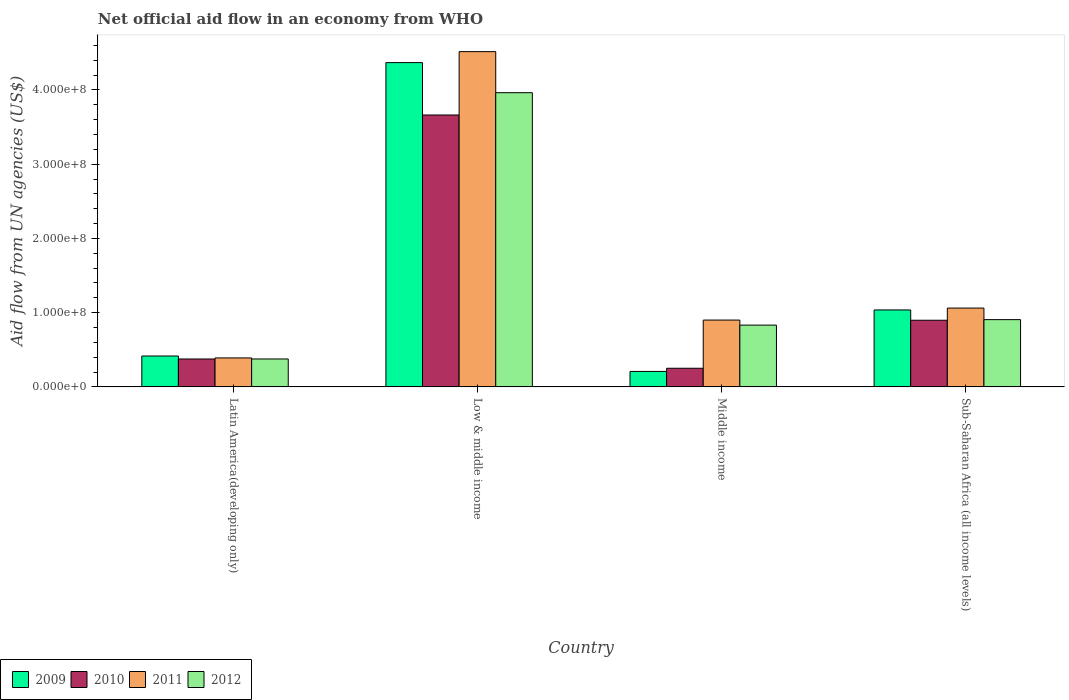Are the number of bars per tick equal to the number of legend labels?
Ensure brevity in your answer.  Yes. Are the number of bars on each tick of the X-axis equal?
Give a very brief answer. Yes. How many bars are there on the 3rd tick from the right?
Provide a succinct answer. 4. What is the label of the 3rd group of bars from the left?
Keep it short and to the point. Middle income. In how many cases, is the number of bars for a given country not equal to the number of legend labels?
Make the answer very short. 0. What is the net official aid flow in 2009 in Middle income?
Give a very brief answer. 2.08e+07. Across all countries, what is the maximum net official aid flow in 2009?
Provide a short and direct response. 4.37e+08. Across all countries, what is the minimum net official aid flow in 2009?
Offer a terse response. 2.08e+07. In which country was the net official aid flow in 2012 minimum?
Provide a succinct answer. Latin America(developing only). What is the total net official aid flow in 2012 in the graph?
Provide a short and direct response. 6.08e+08. What is the difference between the net official aid flow in 2011 in Latin America(developing only) and that in Sub-Saharan Africa (all income levels)?
Ensure brevity in your answer.  -6.72e+07. What is the difference between the net official aid flow in 2010 in Sub-Saharan Africa (all income levels) and the net official aid flow in 2009 in Middle income?
Make the answer very short. 6.90e+07. What is the average net official aid flow in 2009 per country?
Your response must be concise. 1.51e+08. What is the difference between the net official aid flow of/in 2012 and net official aid flow of/in 2010 in Low & middle income?
Provide a succinct answer. 3.00e+07. In how many countries, is the net official aid flow in 2012 greater than 440000000 US$?
Keep it short and to the point. 0. What is the ratio of the net official aid flow in 2011 in Latin America(developing only) to that in Sub-Saharan Africa (all income levels)?
Give a very brief answer. 0.37. Is the difference between the net official aid flow in 2012 in Latin America(developing only) and Low & middle income greater than the difference between the net official aid flow in 2010 in Latin America(developing only) and Low & middle income?
Your answer should be compact. No. What is the difference between the highest and the second highest net official aid flow in 2012?
Your response must be concise. 3.06e+08. What is the difference between the highest and the lowest net official aid flow in 2009?
Ensure brevity in your answer.  4.16e+08. Is it the case that in every country, the sum of the net official aid flow in 2012 and net official aid flow in 2009 is greater than the sum of net official aid flow in 2011 and net official aid flow in 2010?
Offer a very short reply. No. What does the 4th bar from the right in Middle income represents?
Ensure brevity in your answer.  2009. How many bars are there?
Make the answer very short. 16. Are all the bars in the graph horizontal?
Make the answer very short. No. How many countries are there in the graph?
Ensure brevity in your answer.  4. Does the graph contain grids?
Your response must be concise. No. How many legend labels are there?
Provide a succinct answer. 4. How are the legend labels stacked?
Provide a succinct answer. Horizontal. What is the title of the graph?
Your response must be concise. Net official aid flow in an economy from WHO. What is the label or title of the Y-axis?
Your answer should be very brief. Aid flow from UN agencies (US$). What is the Aid flow from UN agencies (US$) in 2009 in Latin America(developing only)?
Keep it short and to the point. 4.16e+07. What is the Aid flow from UN agencies (US$) of 2010 in Latin America(developing only)?
Provide a succinct answer. 3.76e+07. What is the Aid flow from UN agencies (US$) in 2011 in Latin America(developing only)?
Keep it short and to the point. 3.90e+07. What is the Aid flow from UN agencies (US$) of 2012 in Latin America(developing only)?
Ensure brevity in your answer.  3.76e+07. What is the Aid flow from UN agencies (US$) in 2009 in Low & middle income?
Your answer should be compact. 4.37e+08. What is the Aid flow from UN agencies (US$) in 2010 in Low & middle income?
Ensure brevity in your answer.  3.66e+08. What is the Aid flow from UN agencies (US$) of 2011 in Low & middle income?
Your response must be concise. 4.52e+08. What is the Aid flow from UN agencies (US$) of 2012 in Low & middle income?
Ensure brevity in your answer.  3.96e+08. What is the Aid flow from UN agencies (US$) in 2009 in Middle income?
Offer a very short reply. 2.08e+07. What is the Aid flow from UN agencies (US$) in 2010 in Middle income?
Provide a short and direct response. 2.51e+07. What is the Aid flow from UN agencies (US$) in 2011 in Middle income?
Ensure brevity in your answer.  9.00e+07. What is the Aid flow from UN agencies (US$) in 2012 in Middle income?
Provide a succinct answer. 8.32e+07. What is the Aid flow from UN agencies (US$) in 2009 in Sub-Saharan Africa (all income levels)?
Provide a succinct answer. 1.04e+08. What is the Aid flow from UN agencies (US$) of 2010 in Sub-Saharan Africa (all income levels)?
Ensure brevity in your answer.  8.98e+07. What is the Aid flow from UN agencies (US$) of 2011 in Sub-Saharan Africa (all income levels)?
Your response must be concise. 1.06e+08. What is the Aid flow from UN agencies (US$) in 2012 in Sub-Saharan Africa (all income levels)?
Offer a terse response. 9.06e+07. Across all countries, what is the maximum Aid flow from UN agencies (US$) in 2009?
Provide a succinct answer. 4.37e+08. Across all countries, what is the maximum Aid flow from UN agencies (US$) of 2010?
Your answer should be very brief. 3.66e+08. Across all countries, what is the maximum Aid flow from UN agencies (US$) of 2011?
Your response must be concise. 4.52e+08. Across all countries, what is the maximum Aid flow from UN agencies (US$) in 2012?
Offer a terse response. 3.96e+08. Across all countries, what is the minimum Aid flow from UN agencies (US$) of 2009?
Your answer should be compact. 2.08e+07. Across all countries, what is the minimum Aid flow from UN agencies (US$) in 2010?
Ensure brevity in your answer.  2.51e+07. Across all countries, what is the minimum Aid flow from UN agencies (US$) of 2011?
Offer a terse response. 3.90e+07. Across all countries, what is the minimum Aid flow from UN agencies (US$) in 2012?
Your response must be concise. 3.76e+07. What is the total Aid flow from UN agencies (US$) of 2009 in the graph?
Your response must be concise. 6.03e+08. What is the total Aid flow from UN agencies (US$) of 2010 in the graph?
Ensure brevity in your answer.  5.19e+08. What is the total Aid flow from UN agencies (US$) in 2011 in the graph?
Your response must be concise. 6.87e+08. What is the total Aid flow from UN agencies (US$) in 2012 in the graph?
Give a very brief answer. 6.08e+08. What is the difference between the Aid flow from UN agencies (US$) in 2009 in Latin America(developing only) and that in Low & middle income?
Provide a short and direct response. -3.95e+08. What is the difference between the Aid flow from UN agencies (US$) of 2010 in Latin America(developing only) and that in Low & middle income?
Provide a short and direct response. -3.29e+08. What is the difference between the Aid flow from UN agencies (US$) in 2011 in Latin America(developing only) and that in Low & middle income?
Keep it short and to the point. -4.13e+08. What is the difference between the Aid flow from UN agencies (US$) of 2012 in Latin America(developing only) and that in Low & middle income?
Your answer should be compact. -3.59e+08. What is the difference between the Aid flow from UN agencies (US$) of 2009 in Latin America(developing only) and that in Middle income?
Provide a succinct answer. 2.08e+07. What is the difference between the Aid flow from UN agencies (US$) of 2010 in Latin America(developing only) and that in Middle income?
Offer a terse response. 1.25e+07. What is the difference between the Aid flow from UN agencies (US$) of 2011 in Latin America(developing only) and that in Middle income?
Make the answer very short. -5.10e+07. What is the difference between the Aid flow from UN agencies (US$) in 2012 in Latin America(developing only) and that in Middle income?
Your answer should be very brief. -4.56e+07. What is the difference between the Aid flow from UN agencies (US$) in 2009 in Latin America(developing only) and that in Sub-Saharan Africa (all income levels)?
Provide a succinct answer. -6.20e+07. What is the difference between the Aid flow from UN agencies (US$) in 2010 in Latin America(developing only) and that in Sub-Saharan Africa (all income levels)?
Offer a very short reply. -5.22e+07. What is the difference between the Aid flow from UN agencies (US$) in 2011 in Latin America(developing only) and that in Sub-Saharan Africa (all income levels)?
Your response must be concise. -6.72e+07. What is the difference between the Aid flow from UN agencies (US$) of 2012 in Latin America(developing only) and that in Sub-Saharan Africa (all income levels)?
Give a very brief answer. -5.30e+07. What is the difference between the Aid flow from UN agencies (US$) in 2009 in Low & middle income and that in Middle income?
Offer a terse response. 4.16e+08. What is the difference between the Aid flow from UN agencies (US$) in 2010 in Low & middle income and that in Middle income?
Give a very brief answer. 3.41e+08. What is the difference between the Aid flow from UN agencies (US$) of 2011 in Low & middle income and that in Middle income?
Ensure brevity in your answer.  3.62e+08. What is the difference between the Aid flow from UN agencies (US$) in 2012 in Low & middle income and that in Middle income?
Your answer should be compact. 3.13e+08. What is the difference between the Aid flow from UN agencies (US$) in 2009 in Low & middle income and that in Sub-Saharan Africa (all income levels)?
Provide a short and direct response. 3.33e+08. What is the difference between the Aid flow from UN agencies (US$) of 2010 in Low & middle income and that in Sub-Saharan Africa (all income levels)?
Give a very brief answer. 2.76e+08. What is the difference between the Aid flow from UN agencies (US$) in 2011 in Low & middle income and that in Sub-Saharan Africa (all income levels)?
Give a very brief answer. 3.45e+08. What is the difference between the Aid flow from UN agencies (US$) in 2012 in Low & middle income and that in Sub-Saharan Africa (all income levels)?
Your answer should be compact. 3.06e+08. What is the difference between the Aid flow from UN agencies (US$) of 2009 in Middle income and that in Sub-Saharan Africa (all income levels)?
Give a very brief answer. -8.28e+07. What is the difference between the Aid flow from UN agencies (US$) in 2010 in Middle income and that in Sub-Saharan Africa (all income levels)?
Offer a very short reply. -6.47e+07. What is the difference between the Aid flow from UN agencies (US$) in 2011 in Middle income and that in Sub-Saharan Africa (all income levels)?
Ensure brevity in your answer.  -1.62e+07. What is the difference between the Aid flow from UN agencies (US$) in 2012 in Middle income and that in Sub-Saharan Africa (all income levels)?
Keep it short and to the point. -7.39e+06. What is the difference between the Aid flow from UN agencies (US$) of 2009 in Latin America(developing only) and the Aid flow from UN agencies (US$) of 2010 in Low & middle income?
Your answer should be compact. -3.25e+08. What is the difference between the Aid flow from UN agencies (US$) in 2009 in Latin America(developing only) and the Aid flow from UN agencies (US$) in 2011 in Low & middle income?
Your answer should be compact. -4.10e+08. What is the difference between the Aid flow from UN agencies (US$) of 2009 in Latin America(developing only) and the Aid flow from UN agencies (US$) of 2012 in Low & middle income?
Your answer should be very brief. -3.55e+08. What is the difference between the Aid flow from UN agencies (US$) in 2010 in Latin America(developing only) and the Aid flow from UN agencies (US$) in 2011 in Low & middle income?
Provide a short and direct response. -4.14e+08. What is the difference between the Aid flow from UN agencies (US$) of 2010 in Latin America(developing only) and the Aid flow from UN agencies (US$) of 2012 in Low & middle income?
Ensure brevity in your answer.  -3.59e+08. What is the difference between the Aid flow from UN agencies (US$) in 2011 in Latin America(developing only) and the Aid flow from UN agencies (US$) in 2012 in Low & middle income?
Your answer should be very brief. -3.57e+08. What is the difference between the Aid flow from UN agencies (US$) of 2009 in Latin America(developing only) and the Aid flow from UN agencies (US$) of 2010 in Middle income?
Your response must be concise. 1.65e+07. What is the difference between the Aid flow from UN agencies (US$) of 2009 in Latin America(developing only) and the Aid flow from UN agencies (US$) of 2011 in Middle income?
Keep it short and to the point. -4.84e+07. What is the difference between the Aid flow from UN agencies (US$) in 2009 in Latin America(developing only) and the Aid flow from UN agencies (US$) in 2012 in Middle income?
Keep it short and to the point. -4.16e+07. What is the difference between the Aid flow from UN agencies (US$) in 2010 in Latin America(developing only) and the Aid flow from UN agencies (US$) in 2011 in Middle income?
Give a very brief answer. -5.24e+07. What is the difference between the Aid flow from UN agencies (US$) in 2010 in Latin America(developing only) and the Aid flow from UN agencies (US$) in 2012 in Middle income?
Your answer should be very brief. -4.56e+07. What is the difference between the Aid flow from UN agencies (US$) of 2011 in Latin America(developing only) and the Aid flow from UN agencies (US$) of 2012 in Middle income?
Your answer should be very brief. -4.42e+07. What is the difference between the Aid flow from UN agencies (US$) of 2009 in Latin America(developing only) and the Aid flow from UN agencies (US$) of 2010 in Sub-Saharan Africa (all income levels)?
Provide a short and direct response. -4.82e+07. What is the difference between the Aid flow from UN agencies (US$) of 2009 in Latin America(developing only) and the Aid flow from UN agencies (US$) of 2011 in Sub-Saharan Africa (all income levels)?
Offer a very short reply. -6.46e+07. What is the difference between the Aid flow from UN agencies (US$) of 2009 in Latin America(developing only) and the Aid flow from UN agencies (US$) of 2012 in Sub-Saharan Africa (all income levels)?
Your answer should be very brief. -4.90e+07. What is the difference between the Aid flow from UN agencies (US$) of 2010 in Latin America(developing only) and the Aid flow from UN agencies (US$) of 2011 in Sub-Saharan Africa (all income levels)?
Ensure brevity in your answer.  -6.86e+07. What is the difference between the Aid flow from UN agencies (US$) in 2010 in Latin America(developing only) and the Aid flow from UN agencies (US$) in 2012 in Sub-Saharan Africa (all income levels)?
Keep it short and to the point. -5.30e+07. What is the difference between the Aid flow from UN agencies (US$) of 2011 in Latin America(developing only) and the Aid flow from UN agencies (US$) of 2012 in Sub-Saharan Africa (all income levels)?
Your answer should be compact. -5.16e+07. What is the difference between the Aid flow from UN agencies (US$) of 2009 in Low & middle income and the Aid flow from UN agencies (US$) of 2010 in Middle income?
Your response must be concise. 4.12e+08. What is the difference between the Aid flow from UN agencies (US$) in 2009 in Low & middle income and the Aid flow from UN agencies (US$) in 2011 in Middle income?
Offer a very short reply. 3.47e+08. What is the difference between the Aid flow from UN agencies (US$) of 2009 in Low & middle income and the Aid flow from UN agencies (US$) of 2012 in Middle income?
Offer a terse response. 3.54e+08. What is the difference between the Aid flow from UN agencies (US$) of 2010 in Low & middle income and the Aid flow from UN agencies (US$) of 2011 in Middle income?
Give a very brief answer. 2.76e+08. What is the difference between the Aid flow from UN agencies (US$) of 2010 in Low & middle income and the Aid flow from UN agencies (US$) of 2012 in Middle income?
Provide a succinct answer. 2.83e+08. What is the difference between the Aid flow from UN agencies (US$) of 2011 in Low & middle income and the Aid flow from UN agencies (US$) of 2012 in Middle income?
Your answer should be very brief. 3.68e+08. What is the difference between the Aid flow from UN agencies (US$) in 2009 in Low & middle income and the Aid flow from UN agencies (US$) in 2010 in Sub-Saharan Africa (all income levels)?
Ensure brevity in your answer.  3.47e+08. What is the difference between the Aid flow from UN agencies (US$) in 2009 in Low & middle income and the Aid flow from UN agencies (US$) in 2011 in Sub-Saharan Africa (all income levels)?
Offer a very short reply. 3.31e+08. What is the difference between the Aid flow from UN agencies (US$) of 2009 in Low & middle income and the Aid flow from UN agencies (US$) of 2012 in Sub-Saharan Africa (all income levels)?
Offer a terse response. 3.46e+08. What is the difference between the Aid flow from UN agencies (US$) in 2010 in Low & middle income and the Aid flow from UN agencies (US$) in 2011 in Sub-Saharan Africa (all income levels)?
Your answer should be compact. 2.60e+08. What is the difference between the Aid flow from UN agencies (US$) in 2010 in Low & middle income and the Aid flow from UN agencies (US$) in 2012 in Sub-Saharan Africa (all income levels)?
Offer a very short reply. 2.76e+08. What is the difference between the Aid flow from UN agencies (US$) in 2011 in Low & middle income and the Aid flow from UN agencies (US$) in 2012 in Sub-Saharan Africa (all income levels)?
Provide a succinct answer. 3.61e+08. What is the difference between the Aid flow from UN agencies (US$) of 2009 in Middle income and the Aid flow from UN agencies (US$) of 2010 in Sub-Saharan Africa (all income levels)?
Make the answer very short. -6.90e+07. What is the difference between the Aid flow from UN agencies (US$) of 2009 in Middle income and the Aid flow from UN agencies (US$) of 2011 in Sub-Saharan Africa (all income levels)?
Your answer should be very brief. -8.54e+07. What is the difference between the Aid flow from UN agencies (US$) in 2009 in Middle income and the Aid flow from UN agencies (US$) in 2012 in Sub-Saharan Africa (all income levels)?
Make the answer very short. -6.98e+07. What is the difference between the Aid flow from UN agencies (US$) in 2010 in Middle income and the Aid flow from UN agencies (US$) in 2011 in Sub-Saharan Africa (all income levels)?
Give a very brief answer. -8.11e+07. What is the difference between the Aid flow from UN agencies (US$) of 2010 in Middle income and the Aid flow from UN agencies (US$) of 2012 in Sub-Saharan Africa (all income levels)?
Your answer should be very brief. -6.55e+07. What is the difference between the Aid flow from UN agencies (US$) in 2011 in Middle income and the Aid flow from UN agencies (US$) in 2012 in Sub-Saharan Africa (all income levels)?
Your answer should be compact. -5.90e+05. What is the average Aid flow from UN agencies (US$) in 2009 per country?
Keep it short and to the point. 1.51e+08. What is the average Aid flow from UN agencies (US$) in 2010 per country?
Give a very brief answer. 1.30e+08. What is the average Aid flow from UN agencies (US$) in 2011 per country?
Offer a terse response. 1.72e+08. What is the average Aid flow from UN agencies (US$) in 2012 per country?
Offer a very short reply. 1.52e+08. What is the difference between the Aid flow from UN agencies (US$) in 2009 and Aid flow from UN agencies (US$) in 2010 in Latin America(developing only)?
Provide a succinct answer. 4.01e+06. What is the difference between the Aid flow from UN agencies (US$) of 2009 and Aid flow from UN agencies (US$) of 2011 in Latin America(developing only)?
Give a very brief answer. 2.59e+06. What is the difference between the Aid flow from UN agencies (US$) in 2009 and Aid flow from UN agencies (US$) in 2012 in Latin America(developing only)?
Your answer should be compact. 3.99e+06. What is the difference between the Aid flow from UN agencies (US$) of 2010 and Aid flow from UN agencies (US$) of 2011 in Latin America(developing only)?
Offer a terse response. -1.42e+06. What is the difference between the Aid flow from UN agencies (US$) of 2010 and Aid flow from UN agencies (US$) of 2012 in Latin America(developing only)?
Ensure brevity in your answer.  -2.00e+04. What is the difference between the Aid flow from UN agencies (US$) of 2011 and Aid flow from UN agencies (US$) of 2012 in Latin America(developing only)?
Your response must be concise. 1.40e+06. What is the difference between the Aid flow from UN agencies (US$) of 2009 and Aid flow from UN agencies (US$) of 2010 in Low & middle income?
Your response must be concise. 7.06e+07. What is the difference between the Aid flow from UN agencies (US$) of 2009 and Aid flow from UN agencies (US$) of 2011 in Low & middle income?
Give a very brief answer. -1.48e+07. What is the difference between the Aid flow from UN agencies (US$) in 2009 and Aid flow from UN agencies (US$) in 2012 in Low & middle income?
Your answer should be compact. 4.05e+07. What is the difference between the Aid flow from UN agencies (US$) of 2010 and Aid flow from UN agencies (US$) of 2011 in Low & middle income?
Keep it short and to the point. -8.54e+07. What is the difference between the Aid flow from UN agencies (US$) of 2010 and Aid flow from UN agencies (US$) of 2012 in Low & middle income?
Provide a succinct answer. -3.00e+07. What is the difference between the Aid flow from UN agencies (US$) of 2011 and Aid flow from UN agencies (US$) of 2012 in Low & middle income?
Provide a succinct answer. 5.53e+07. What is the difference between the Aid flow from UN agencies (US$) of 2009 and Aid flow from UN agencies (US$) of 2010 in Middle income?
Your answer should be compact. -4.27e+06. What is the difference between the Aid flow from UN agencies (US$) of 2009 and Aid flow from UN agencies (US$) of 2011 in Middle income?
Ensure brevity in your answer.  -6.92e+07. What is the difference between the Aid flow from UN agencies (US$) in 2009 and Aid flow from UN agencies (US$) in 2012 in Middle income?
Offer a very short reply. -6.24e+07. What is the difference between the Aid flow from UN agencies (US$) in 2010 and Aid flow from UN agencies (US$) in 2011 in Middle income?
Make the answer very short. -6.49e+07. What is the difference between the Aid flow from UN agencies (US$) of 2010 and Aid flow from UN agencies (US$) of 2012 in Middle income?
Make the answer very short. -5.81e+07. What is the difference between the Aid flow from UN agencies (US$) of 2011 and Aid flow from UN agencies (US$) of 2012 in Middle income?
Your answer should be compact. 6.80e+06. What is the difference between the Aid flow from UN agencies (US$) of 2009 and Aid flow from UN agencies (US$) of 2010 in Sub-Saharan Africa (all income levels)?
Offer a very short reply. 1.39e+07. What is the difference between the Aid flow from UN agencies (US$) in 2009 and Aid flow from UN agencies (US$) in 2011 in Sub-Saharan Africa (all income levels)?
Make the answer very short. -2.53e+06. What is the difference between the Aid flow from UN agencies (US$) of 2009 and Aid flow from UN agencies (US$) of 2012 in Sub-Saharan Africa (all income levels)?
Provide a short and direct response. 1.30e+07. What is the difference between the Aid flow from UN agencies (US$) of 2010 and Aid flow from UN agencies (US$) of 2011 in Sub-Saharan Africa (all income levels)?
Provide a succinct answer. -1.64e+07. What is the difference between the Aid flow from UN agencies (US$) in 2010 and Aid flow from UN agencies (US$) in 2012 in Sub-Saharan Africa (all income levels)?
Keep it short and to the point. -8.10e+05. What is the difference between the Aid flow from UN agencies (US$) of 2011 and Aid flow from UN agencies (US$) of 2012 in Sub-Saharan Africa (all income levels)?
Your answer should be very brief. 1.56e+07. What is the ratio of the Aid flow from UN agencies (US$) in 2009 in Latin America(developing only) to that in Low & middle income?
Ensure brevity in your answer.  0.1. What is the ratio of the Aid flow from UN agencies (US$) of 2010 in Latin America(developing only) to that in Low & middle income?
Keep it short and to the point. 0.1. What is the ratio of the Aid flow from UN agencies (US$) in 2011 in Latin America(developing only) to that in Low & middle income?
Offer a very short reply. 0.09. What is the ratio of the Aid flow from UN agencies (US$) of 2012 in Latin America(developing only) to that in Low & middle income?
Make the answer very short. 0.09. What is the ratio of the Aid flow from UN agencies (US$) of 2009 in Latin America(developing only) to that in Middle income?
Offer a very short reply. 2. What is the ratio of the Aid flow from UN agencies (US$) of 2010 in Latin America(developing only) to that in Middle income?
Your answer should be very brief. 1.5. What is the ratio of the Aid flow from UN agencies (US$) in 2011 in Latin America(developing only) to that in Middle income?
Ensure brevity in your answer.  0.43. What is the ratio of the Aid flow from UN agencies (US$) of 2012 in Latin America(developing only) to that in Middle income?
Provide a succinct answer. 0.45. What is the ratio of the Aid flow from UN agencies (US$) in 2009 in Latin America(developing only) to that in Sub-Saharan Africa (all income levels)?
Keep it short and to the point. 0.4. What is the ratio of the Aid flow from UN agencies (US$) in 2010 in Latin America(developing only) to that in Sub-Saharan Africa (all income levels)?
Ensure brevity in your answer.  0.42. What is the ratio of the Aid flow from UN agencies (US$) of 2011 in Latin America(developing only) to that in Sub-Saharan Africa (all income levels)?
Make the answer very short. 0.37. What is the ratio of the Aid flow from UN agencies (US$) in 2012 in Latin America(developing only) to that in Sub-Saharan Africa (all income levels)?
Offer a terse response. 0.41. What is the ratio of the Aid flow from UN agencies (US$) in 2009 in Low & middle income to that in Middle income?
Keep it short and to the point. 21. What is the ratio of the Aid flow from UN agencies (US$) in 2010 in Low & middle income to that in Middle income?
Offer a terse response. 14.61. What is the ratio of the Aid flow from UN agencies (US$) of 2011 in Low & middle income to that in Middle income?
Offer a very short reply. 5.02. What is the ratio of the Aid flow from UN agencies (US$) in 2012 in Low & middle income to that in Middle income?
Keep it short and to the point. 4.76. What is the ratio of the Aid flow from UN agencies (US$) in 2009 in Low & middle income to that in Sub-Saharan Africa (all income levels)?
Your response must be concise. 4.22. What is the ratio of the Aid flow from UN agencies (US$) of 2010 in Low & middle income to that in Sub-Saharan Africa (all income levels)?
Give a very brief answer. 4.08. What is the ratio of the Aid flow from UN agencies (US$) in 2011 in Low & middle income to that in Sub-Saharan Africa (all income levels)?
Provide a succinct answer. 4.25. What is the ratio of the Aid flow from UN agencies (US$) in 2012 in Low & middle income to that in Sub-Saharan Africa (all income levels)?
Your answer should be compact. 4.38. What is the ratio of the Aid flow from UN agencies (US$) of 2009 in Middle income to that in Sub-Saharan Africa (all income levels)?
Ensure brevity in your answer.  0.2. What is the ratio of the Aid flow from UN agencies (US$) of 2010 in Middle income to that in Sub-Saharan Africa (all income levels)?
Provide a succinct answer. 0.28. What is the ratio of the Aid flow from UN agencies (US$) in 2011 in Middle income to that in Sub-Saharan Africa (all income levels)?
Make the answer very short. 0.85. What is the ratio of the Aid flow from UN agencies (US$) of 2012 in Middle income to that in Sub-Saharan Africa (all income levels)?
Your answer should be very brief. 0.92. What is the difference between the highest and the second highest Aid flow from UN agencies (US$) of 2009?
Provide a succinct answer. 3.33e+08. What is the difference between the highest and the second highest Aid flow from UN agencies (US$) of 2010?
Give a very brief answer. 2.76e+08. What is the difference between the highest and the second highest Aid flow from UN agencies (US$) of 2011?
Offer a very short reply. 3.45e+08. What is the difference between the highest and the second highest Aid flow from UN agencies (US$) of 2012?
Your answer should be compact. 3.06e+08. What is the difference between the highest and the lowest Aid flow from UN agencies (US$) of 2009?
Give a very brief answer. 4.16e+08. What is the difference between the highest and the lowest Aid flow from UN agencies (US$) in 2010?
Offer a very short reply. 3.41e+08. What is the difference between the highest and the lowest Aid flow from UN agencies (US$) of 2011?
Your answer should be very brief. 4.13e+08. What is the difference between the highest and the lowest Aid flow from UN agencies (US$) of 2012?
Your answer should be very brief. 3.59e+08. 